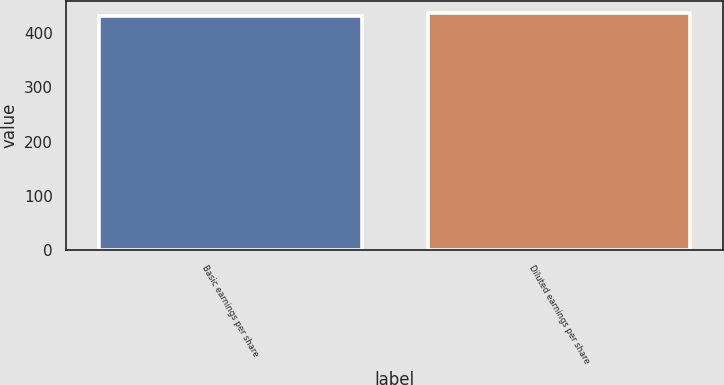Convert chart to OTSL. <chart><loc_0><loc_0><loc_500><loc_500><bar_chart><fcel>Basic earnings per share<fcel>Diluted earnings per share<nl><fcel>431.6<fcel>436.9<nl></chart> 